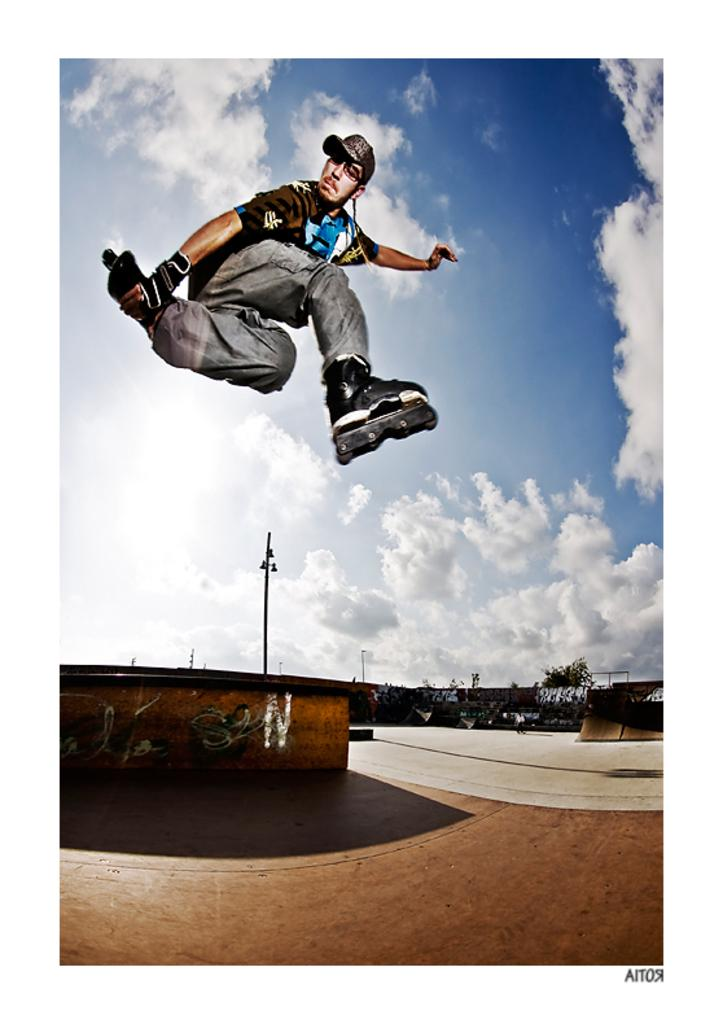What is the person in the image doing? There is a person jumping in the image. What is the surface beneath the person in the image? There is a ground in the image. What can be seen on the wall in the image? There is a wall with a painting in the image. What type of vegetation is visible in the image? There are trees in the image. What material is the board in the image made of? The wooden board in the image is made of wood. What is visible at the top of the image? The sky is visible at the top of the image. What type of apple is being used as a prop in the image? There is no apple present in the image. How many passengers are visible in the image? There are no passengers visible in the image; it features a person jumping. 